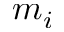<formula> <loc_0><loc_0><loc_500><loc_500>m _ { i }</formula> 